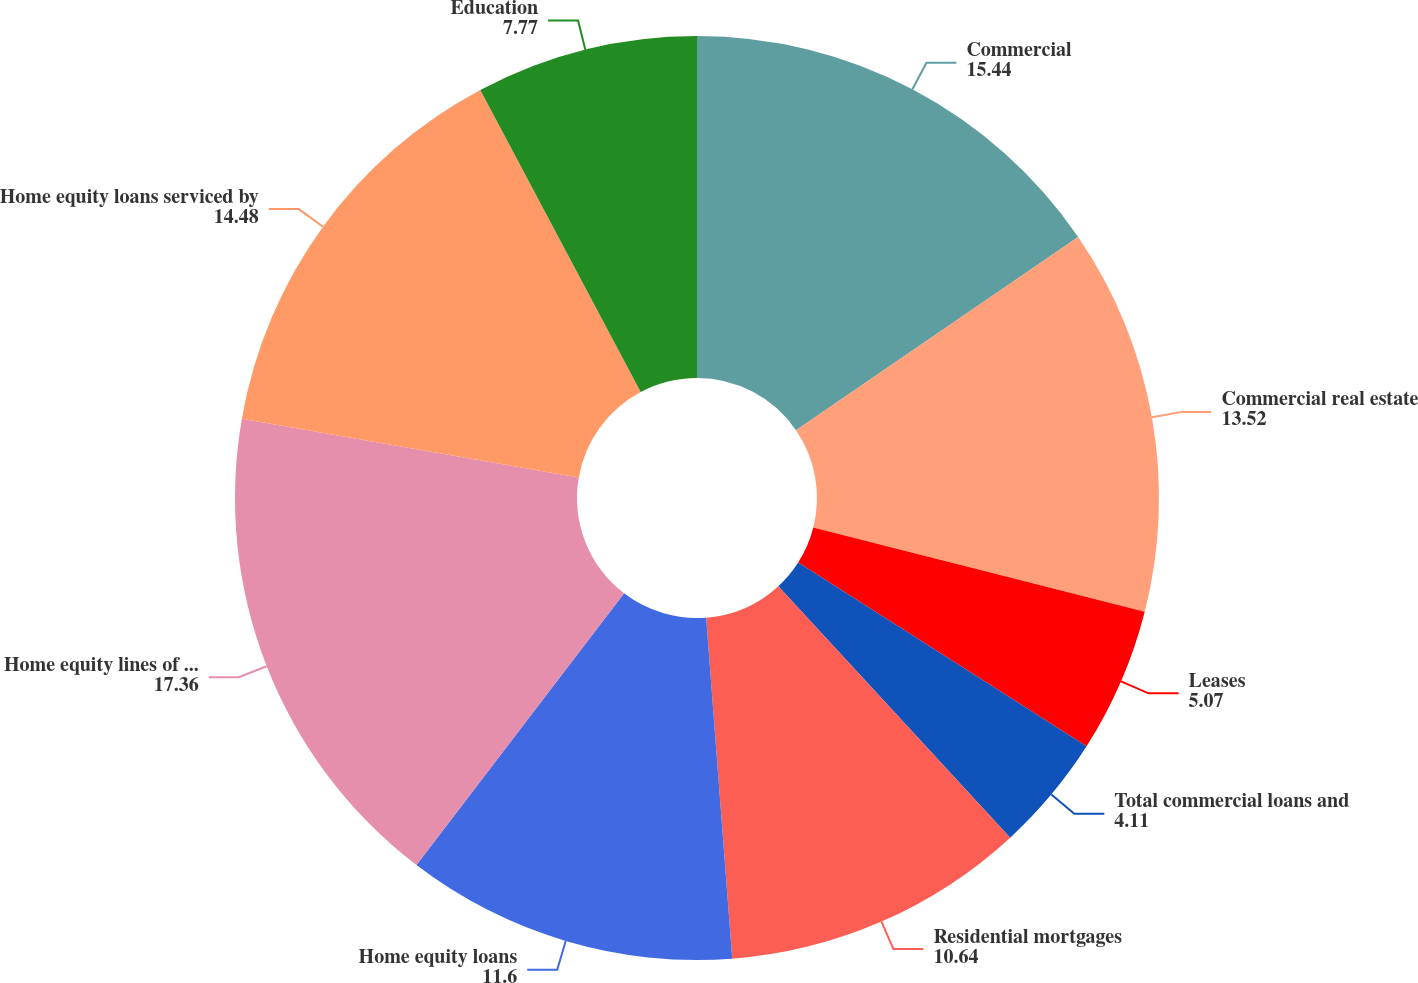<chart> <loc_0><loc_0><loc_500><loc_500><pie_chart><fcel>Commercial<fcel>Commercial real estate<fcel>Leases<fcel>Total commercial loans and<fcel>Residential mortgages<fcel>Home equity loans<fcel>Home equity lines of credit<fcel>Home equity loans serviced by<fcel>Education<nl><fcel>15.44%<fcel>13.52%<fcel>5.07%<fcel>4.11%<fcel>10.64%<fcel>11.6%<fcel>17.36%<fcel>14.48%<fcel>7.77%<nl></chart> 